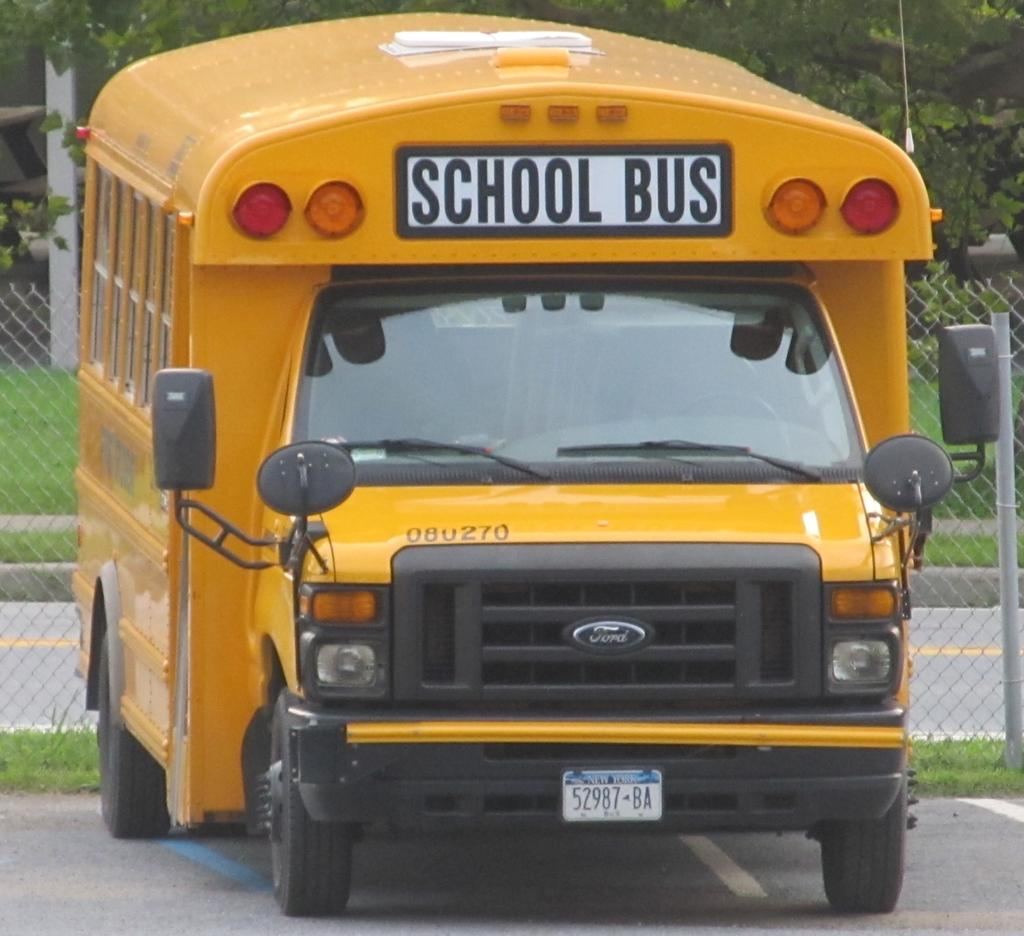<image>
Describe the image concisely. A large yellow school bus manufactured by Ford. 